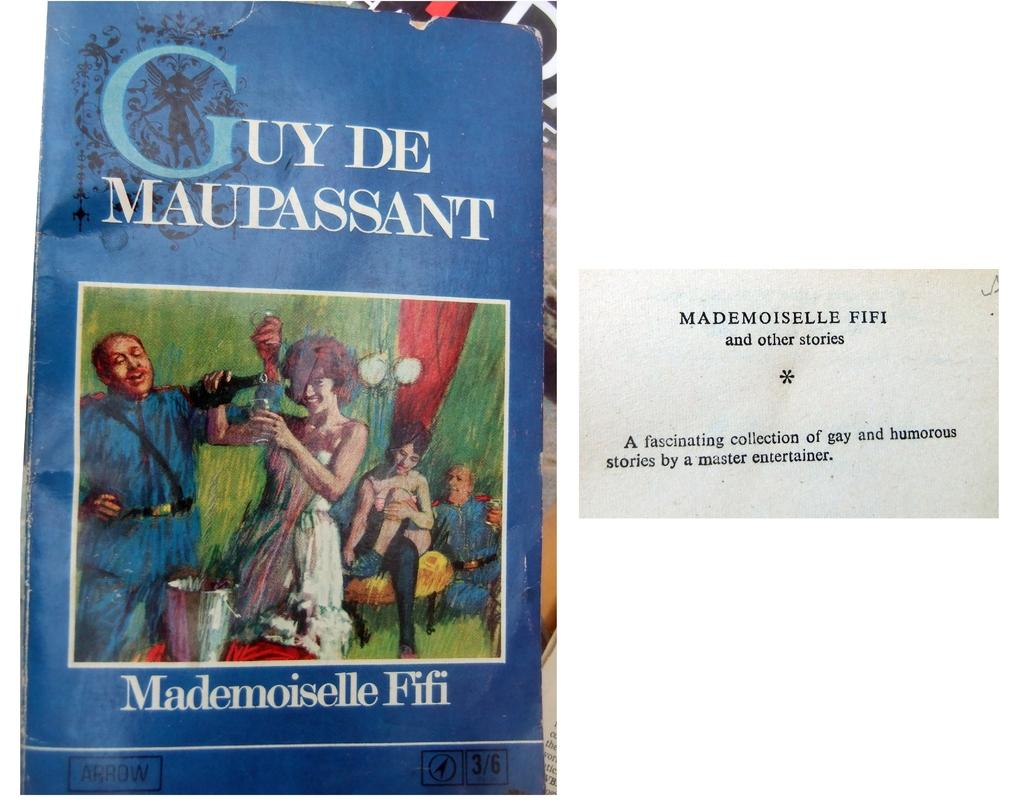<image>
Relay a brief, clear account of the picture shown. The cover of Mademoiselle Fifi is blue with an image of two couples on it. 